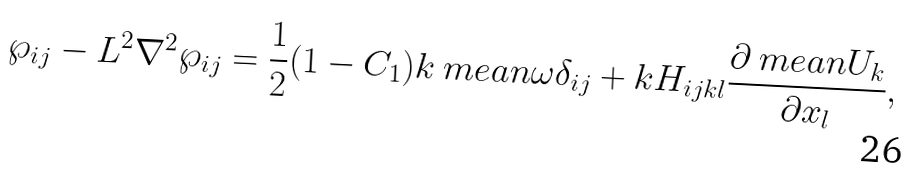<formula> <loc_0><loc_0><loc_500><loc_500>\wp _ { i j } - L ^ { 2 } \nabla ^ { 2 } \wp _ { i j } = \frac { 1 } { 2 } ( 1 - C _ { 1 } ) k \ m e a n { \omega } \delta _ { i j } + k H _ { i j k l } \frac { \partial \ m e a n { U _ { k } } } { \partial x _ { l } } ,</formula> 